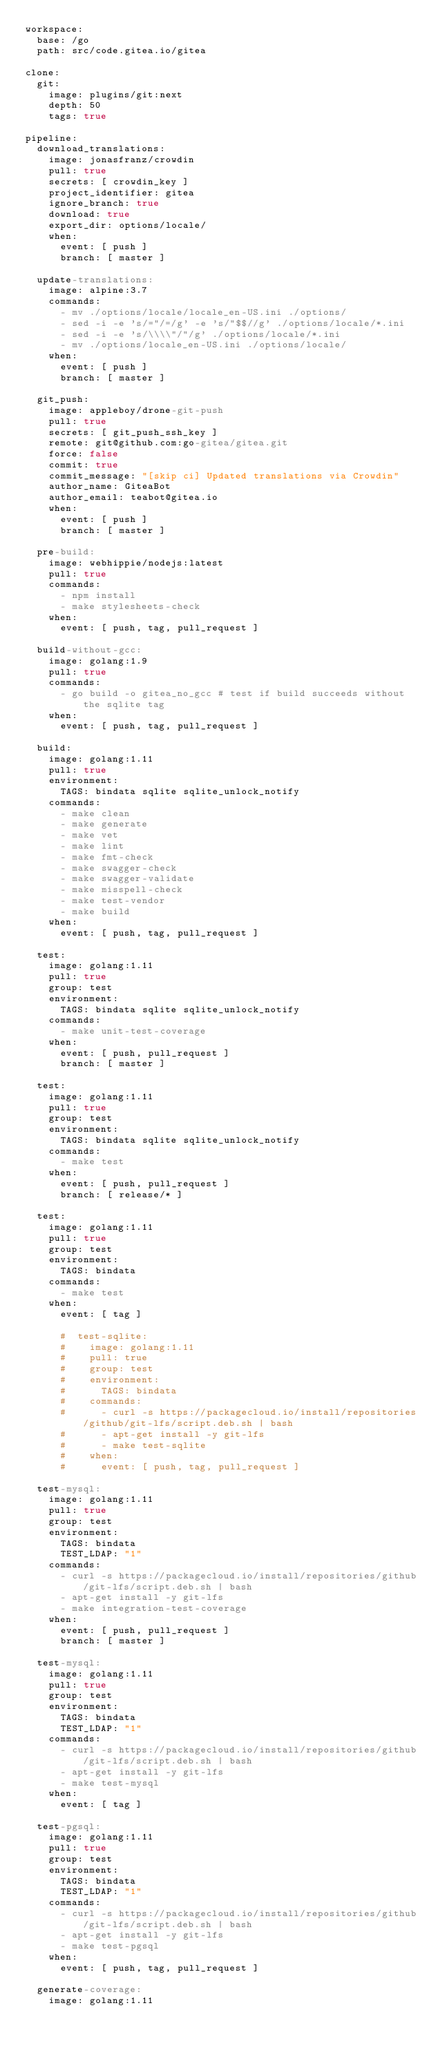<code> <loc_0><loc_0><loc_500><loc_500><_YAML_>workspace:
  base: /go
  path: src/code.gitea.io/gitea

clone:
  git:
    image: plugins/git:next
    depth: 50
    tags: true

pipeline:
  download_translations:
    image: jonasfranz/crowdin
    pull: true
    secrets: [ crowdin_key ]
    project_identifier: gitea
    ignore_branch: true
    download: true
    export_dir: options/locale/
    when:
      event: [ push ]
      branch: [ master ]

  update-translations:
    image: alpine:3.7
    commands:
      - mv ./options/locale/locale_en-US.ini ./options/
      - sed -i -e 's/="/=/g' -e 's/"$$//g' ./options/locale/*.ini
      - sed -i -e 's/\\\\"/"/g' ./options/locale/*.ini
      - mv ./options/locale_en-US.ini ./options/locale/
    when:
      event: [ push ]
      branch: [ master ]

  git_push:
    image: appleboy/drone-git-push
    pull: true
    secrets: [ git_push_ssh_key ]
    remote: git@github.com:go-gitea/gitea.git
    force: false
    commit: true
    commit_message: "[skip ci] Updated translations via Crowdin"
    author_name: GiteaBot
    author_email: teabot@gitea.io
    when:
      event: [ push ]
      branch: [ master ]

  pre-build:
    image: webhippie/nodejs:latest
    pull: true
    commands:
      - npm install
      - make stylesheets-check
    when:
      event: [ push, tag, pull_request ]

  build-without-gcc:
    image: golang:1.9
    pull: true
    commands:
      - go build -o gitea_no_gcc # test if build succeeds without the sqlite tag
    when:
      event: [ push, tag, pull_request ]

  build:
    image: golang:1.11
    pull: true
    environment:
      TAGS: bindata sqlite sqlite_unlock_notify
    commands:
      - make clean
      - make generate
      - make vet
      - make lint
      - make fmt-check
      - make swagger-check
      - make swagger-validate
      - make misspell-check
      - make test-vendor
      - make build
    when:
      event: [ push, tag, pull_request ]

  test:
    image: golang:1.11
    pull: true
    group: test
    environment:
      TAGS: bindata sqlite sqlite_unlock_notify
    commands:
      - make unit-test-coverage
    when:
      event: [ push, pull_request ]
      branch: [ master ]

  test:
    image: golang:1.11
    pull: true
    group: test
    environment:
      TAGS: bindata sqlite sqlite_unlock_notify
    commands:
      - make test
    when:
      event: [ push, pull_request ]
      branch: [ release/* ]

  test:
    image: golang:1.11
    pull: true
    group: test
    environment:
      TAGS: bindata
    commands:
      - make test
    when:
      event: [ tag ]

      #  test-sqlite:
      #    image: golang:1.11
      #    pull: true
      #    group: test
      #    environment:
      #      TAGS: bindata
      #    commands:
      #      - curl -s https://packagecloud.io/install/repositories/github/git-lfs/script.deb.sh | bash
      #      - apt-get install -y git-lfs
      #      - make test-sqlite
      #    when:
      #      event: [ push, tag, pull_request ]

  test-mysql:
    image: golang:1.11
    pull: true
    group: test
    environment:
      TAGS: bindata
      TEST_LDAP: "1"
    commands:
      - curl -s https://packagecloud.io/install/repositories/github/git-lfs/script.deb.sh | bash
      - apt-get install -y git-lfs
      - make integration-test-coverage
    when:
      event: [ push, pull_request ]
      branch: [ master ]

  test-mysql:
    image: golang:1.11
    pull: true
    group: test
    environment:
      TAGS: bindata
      TEST_LDAP: "1"
    commands:
      - curl -s https://packagecloud.io/install/repositories/github/git-lfs/script.deb.sh | bash
      - apt-get install -y git-lfs
      - make test-mysql
    when:
      event: [ tag ]

  test-pgsql:
    image: golang:1.11
    pull: true
    group: test
    environment:
      TAGS: bindata
      TEST_LDAP: "1"
    commands:
      - curl -s https://packagecloud.io/install/repositories/github/git-lfs/script.deb.sh | bash
      - apt-get install -y git-lfs
      - make test-pgsql
    when:
      event: [ push, tag, pull_request ]

  generate-coverage:
    image: golang:1.11</code> 